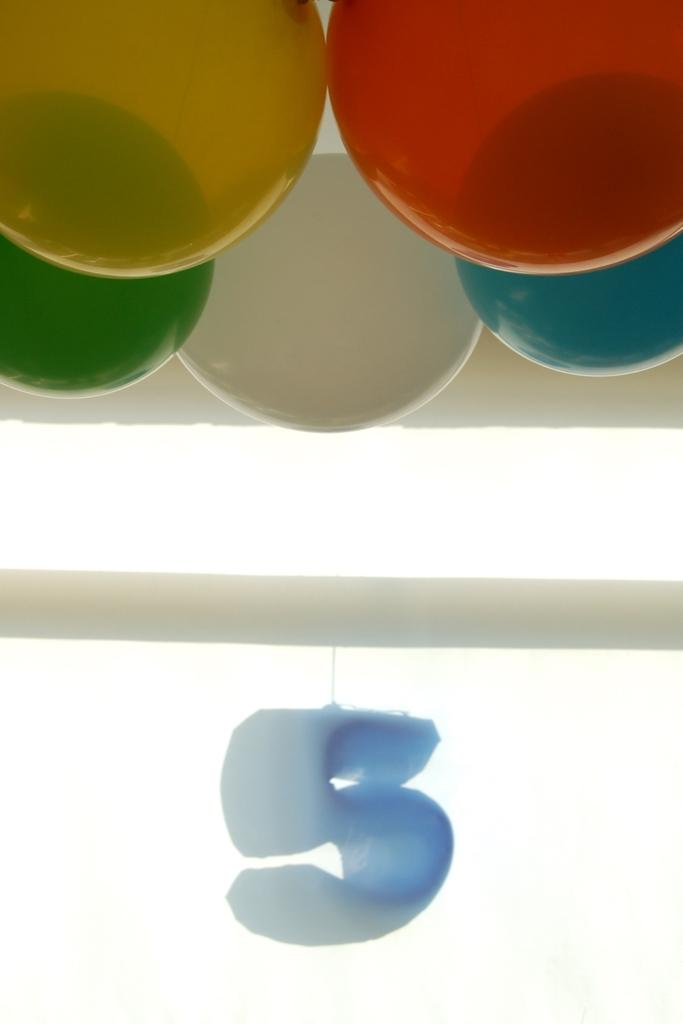What objects are present at the top of the image? There are balloons in the image, and they are located at the top. What is in the center of the image? There is an alphabet in the center of the image. What type of structure can be seen in the image? There is a pole in the image. What is the color of the pole? The pole is white in color. What type of polish is being applied to the balloons in the image? There is no polish being applied to the balloons in the image; they are simply floating at the top. What invention is being demonstrated in the image? There is no specific invention being demonstrated in the image; it primarily features balloons, an alphabet, and a pole. 